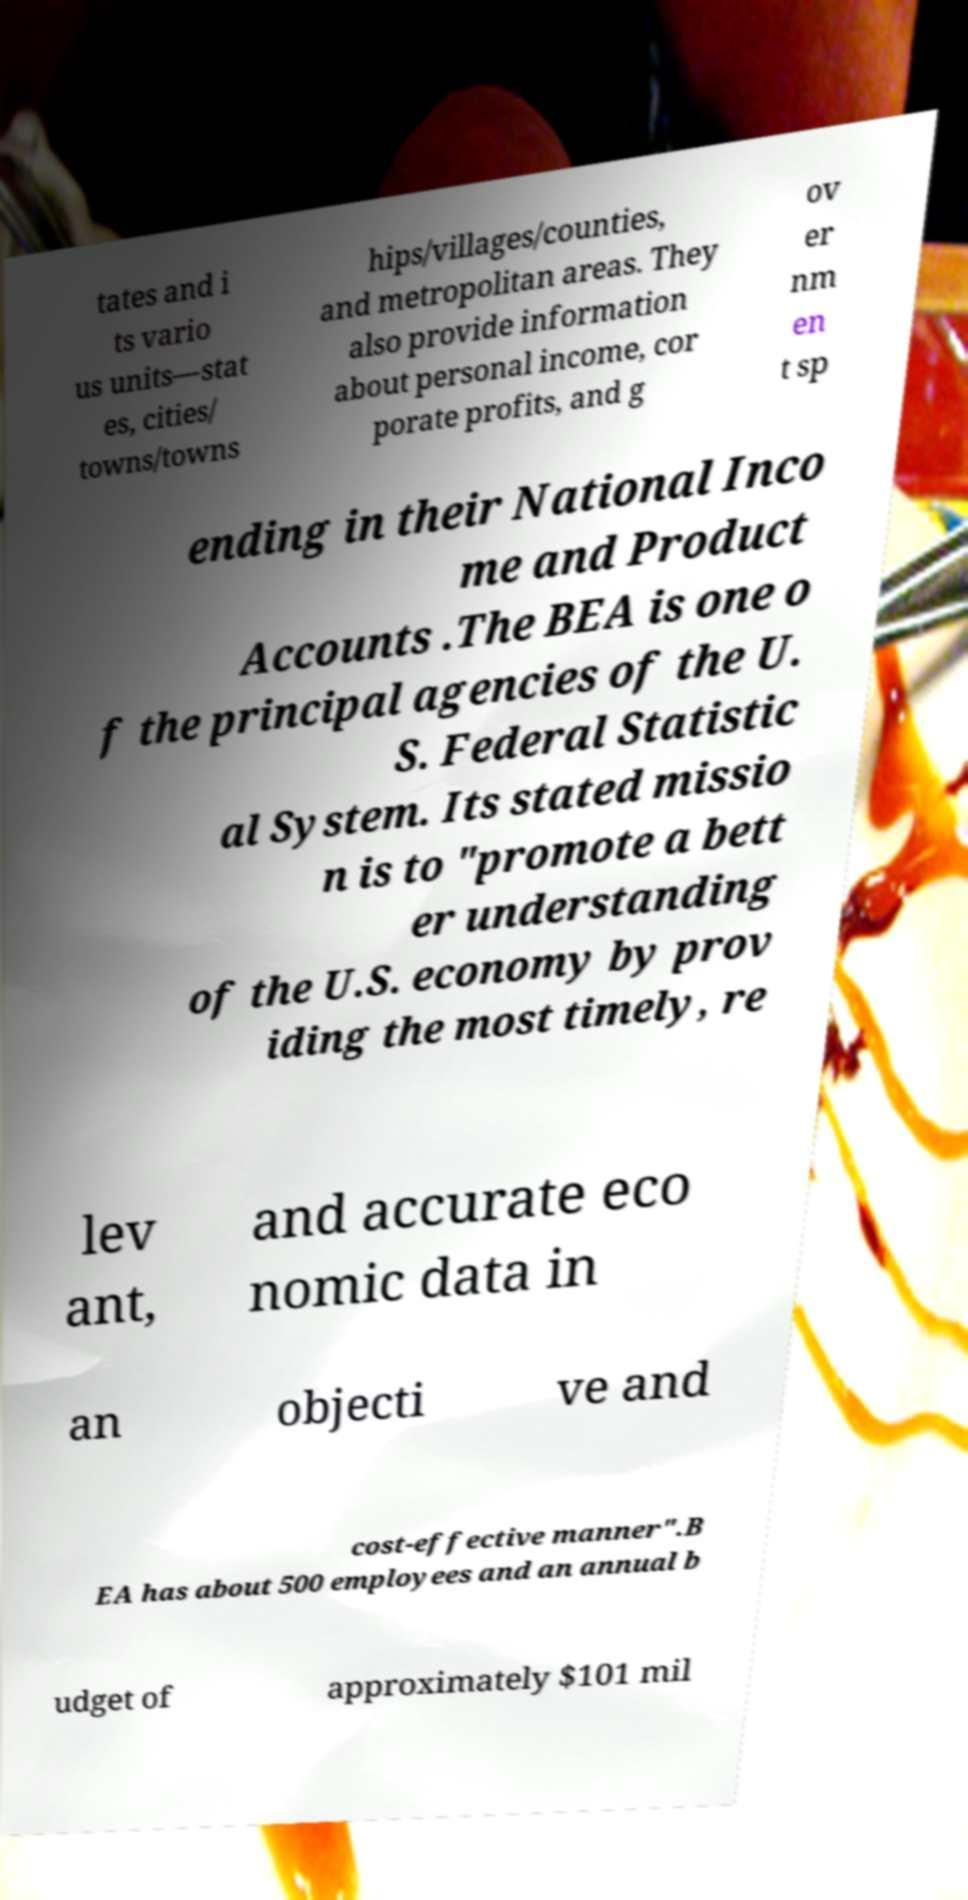Please read and relay the text visible in this image. What does it say? tates and i ts vario us units—stat es, cities/ towns/towns hips/villages/counties, and metropolitan areas. They also provide information about personal income, cor porate profits, and g ov er nm en t sp ending in their National Inco me and Product Accounts .The BEA is one o f the principal agencies of the U. S. Federal Statistic al System. Its stated missio n is to "promote a bett er understanding of the U.S. economy by prov iding the most timely, re lev ant, and accurate eco nomic data in an objecti ve and cost-effective manner".B EA has about 500 employees and an annual b udget of approximately $101 mil 